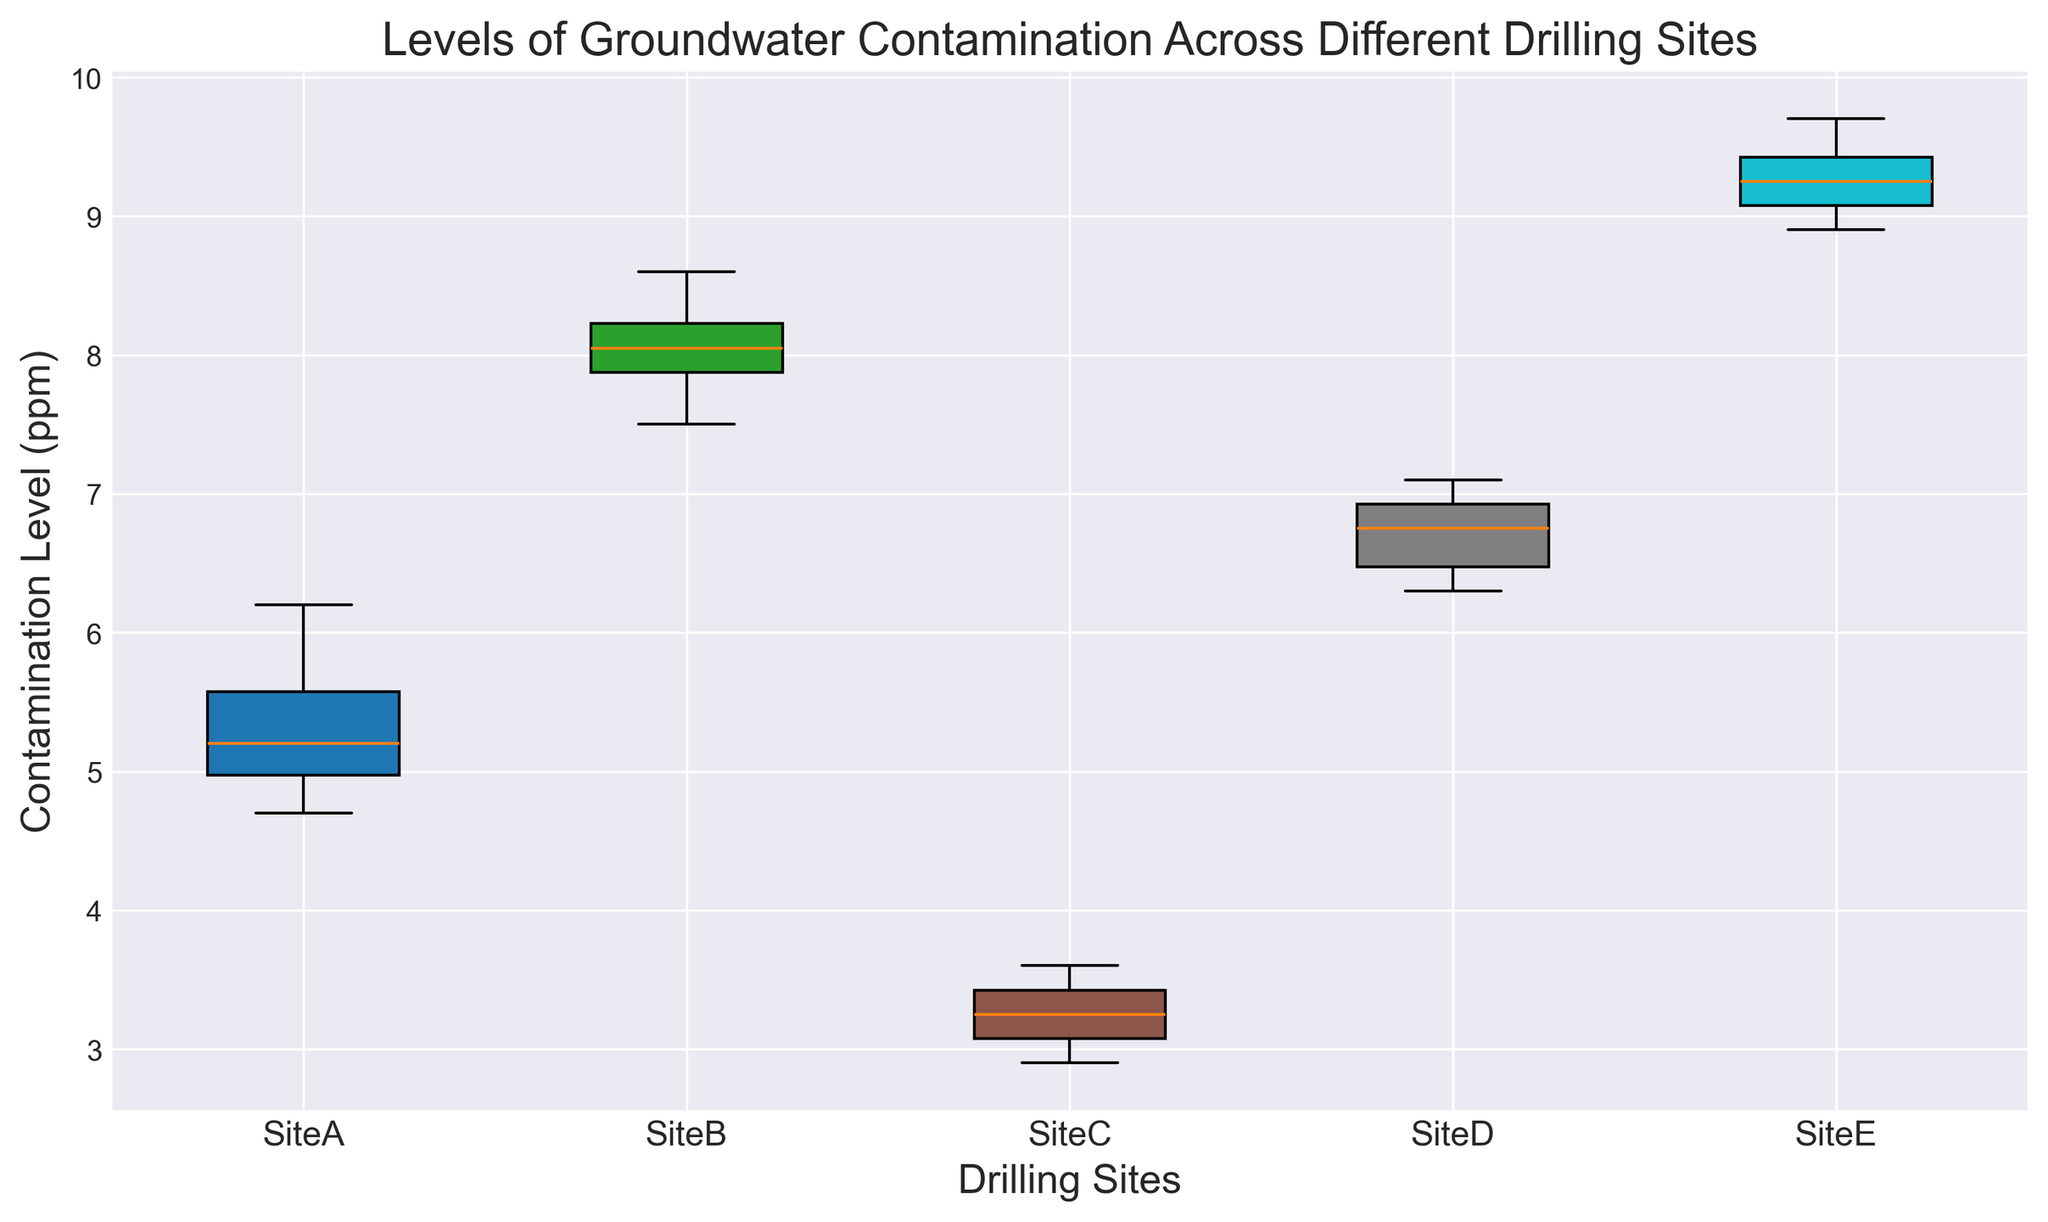What is the median contamination level at Site A? Look at the box plot for Site A. The line inside the box represents the median value.
Answer: 5.1 Which site has the lowest median contamination level? Compare the median lines inside the boxes for all sites. The one lowest on the y-axis is the lowest median contamination level.
Answer: Site C How does the interquartile range (IQR) of Site B compare to that of Site D? The IQR is the height of the box. Compare the height of the boxes for Site B and Site D.
Answer: Site B has a larger IQR than Site D Which site has the highest maximum contamination level? Look at the top whisker of each site. The highest whisker indicates the site with the highest maximum contamination level.
Answer: Site E Is there a site where all data points are above 6 ppm? Verify each site's boxes and whiskers to see if any of them are entirely above 6 ppm.
Answer: Yes, Site E Which site has the widest range of contamination levels? The range is the distance between the top whisker and bottom whisker. Measure the whiskers' lengths for all sites.
Answer: Site E Is the median contamination level for Site D higher or lower than Site A? Compare the median lines inside the boxes for Site D and Site A.
Answer: Higher Does Site C have any outliers? Outliers are shown as points outside the whiskers. Check the plot for Site C.
Answer: No What is the difference in the median contamination levels between Site B and Site C? Find the median values of Site B and Site C, then subtract the smaller from the larger.
Answer: 4.5 ppm Which site has the smallest interquartile range (IQR)? Compare the heights of the boxes for all sites. The smallest box height represents the smallest IQR.
Answer: Site C 